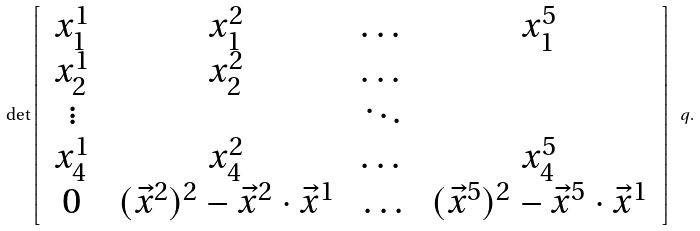<formula> <loc_0><loc_0><loc_500><loc_500>\det \left [ \begin{array} { c c c c } \, x ^ { 1 } _ { 1 } \, & \, x ^ { 2 } _ { 1 } \, & \dots & \, x ^ { 5 } _ { 1 } \, \\ x ^ { 1 } _ { 2 } & x ^ { 2 } _ { 2 } & \dots & \\ \vdots & & \ddots & \\ x ^ { 1 } _ { 4 } & x ^ { 2 } _ { 4 } & \dots & x ^ { 5 } _ { 4 } \\ \, 0 \, & \, ( \vec { x } ^ { 2 } ) ^ { 2 } - \vec { x } ^ { 2 } \cdot \vec { x } ^ { 1 } \, & \, \dots \, & \, ( \vec { x } ^ { 5 } ) ^ { 2 } - \vec { x } ^ { 5 } \cdot \vec { x } ^ { 1 } \, \end{array} \right ] \ q .</formula> 